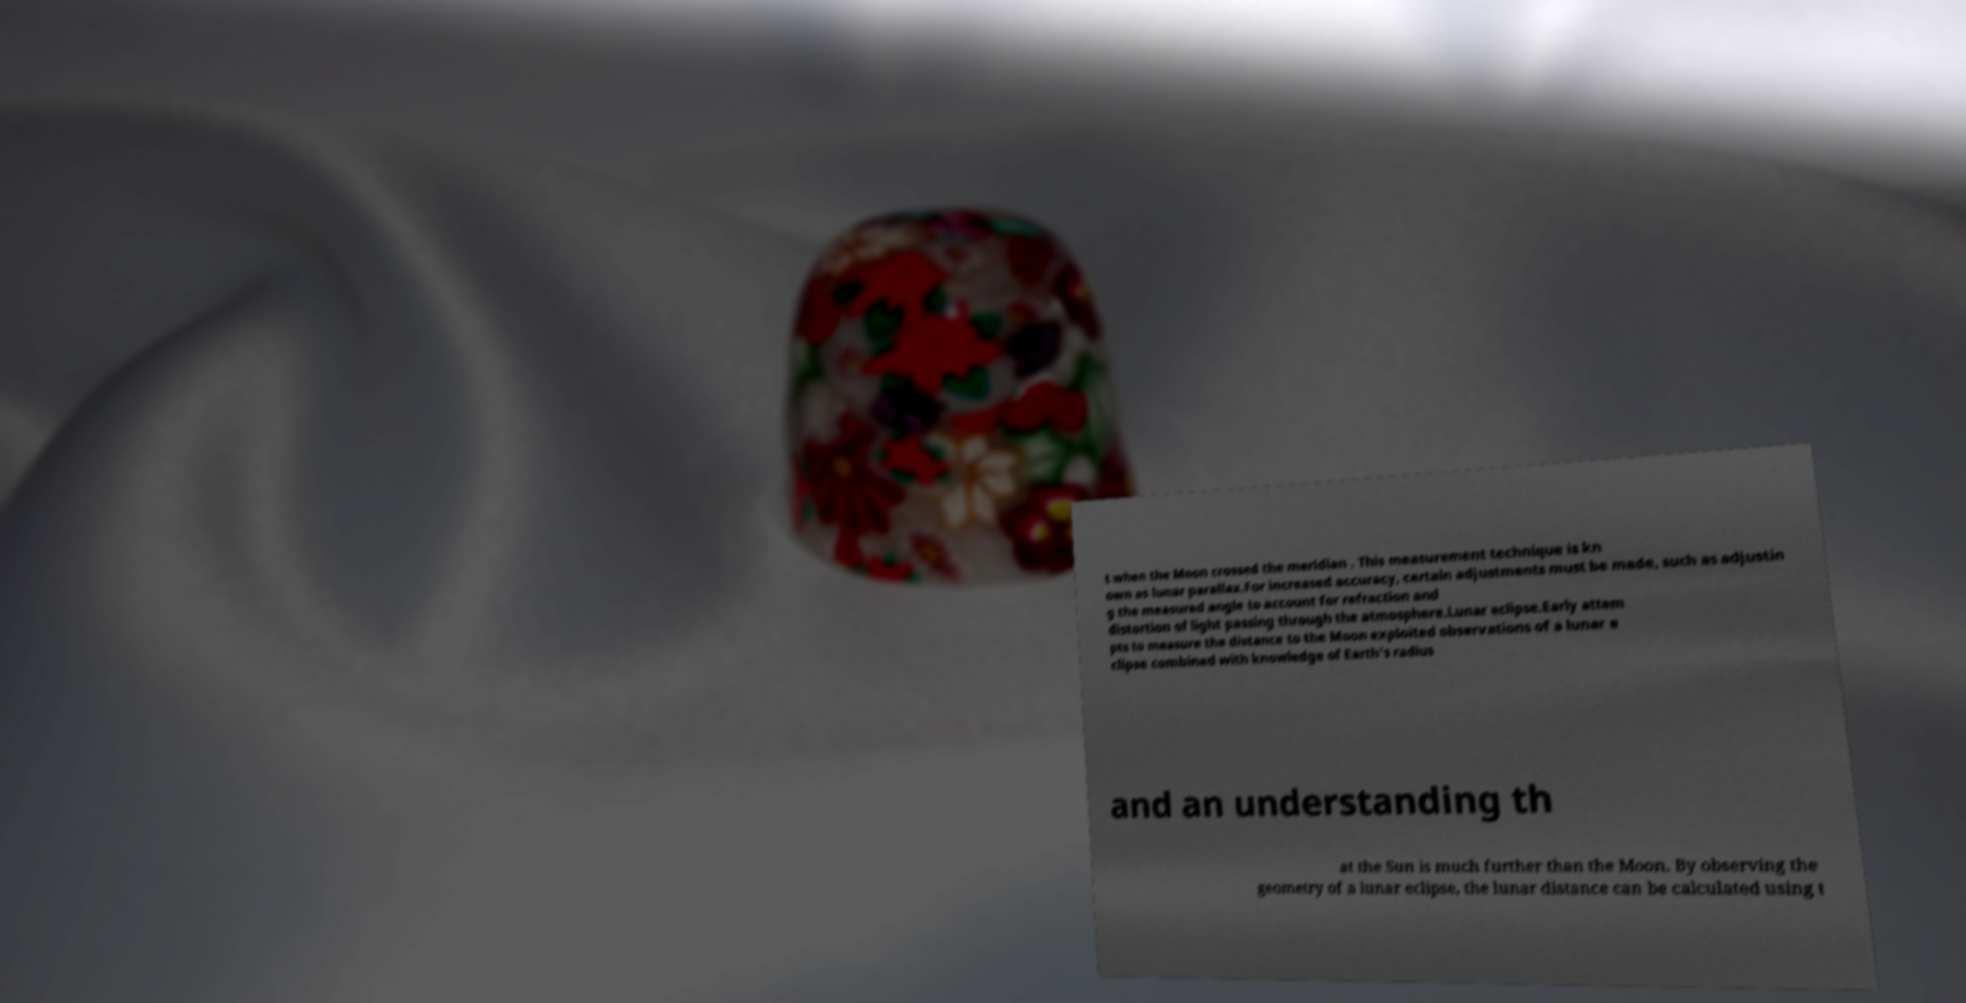Can you accurately transcribe the text from the provided image for me? t when the Moon crossed the meridian . This measurement technique is kn own as lunar parallax.For increased accuracy, certain adjustments must be made, such as adjustin g the measured angle to account for refraction and distortion of light passing through the atmosphere.Lunar eclipse.Early attem pts to measure the distance to the Moon exploited observations of a lunar e clipse combined with knowledge of Earth's radius and an understanding th at the Sun is much further than the Moon. By observing the geometry of a lunar eclipse, the lunar distance can be calculated using t 